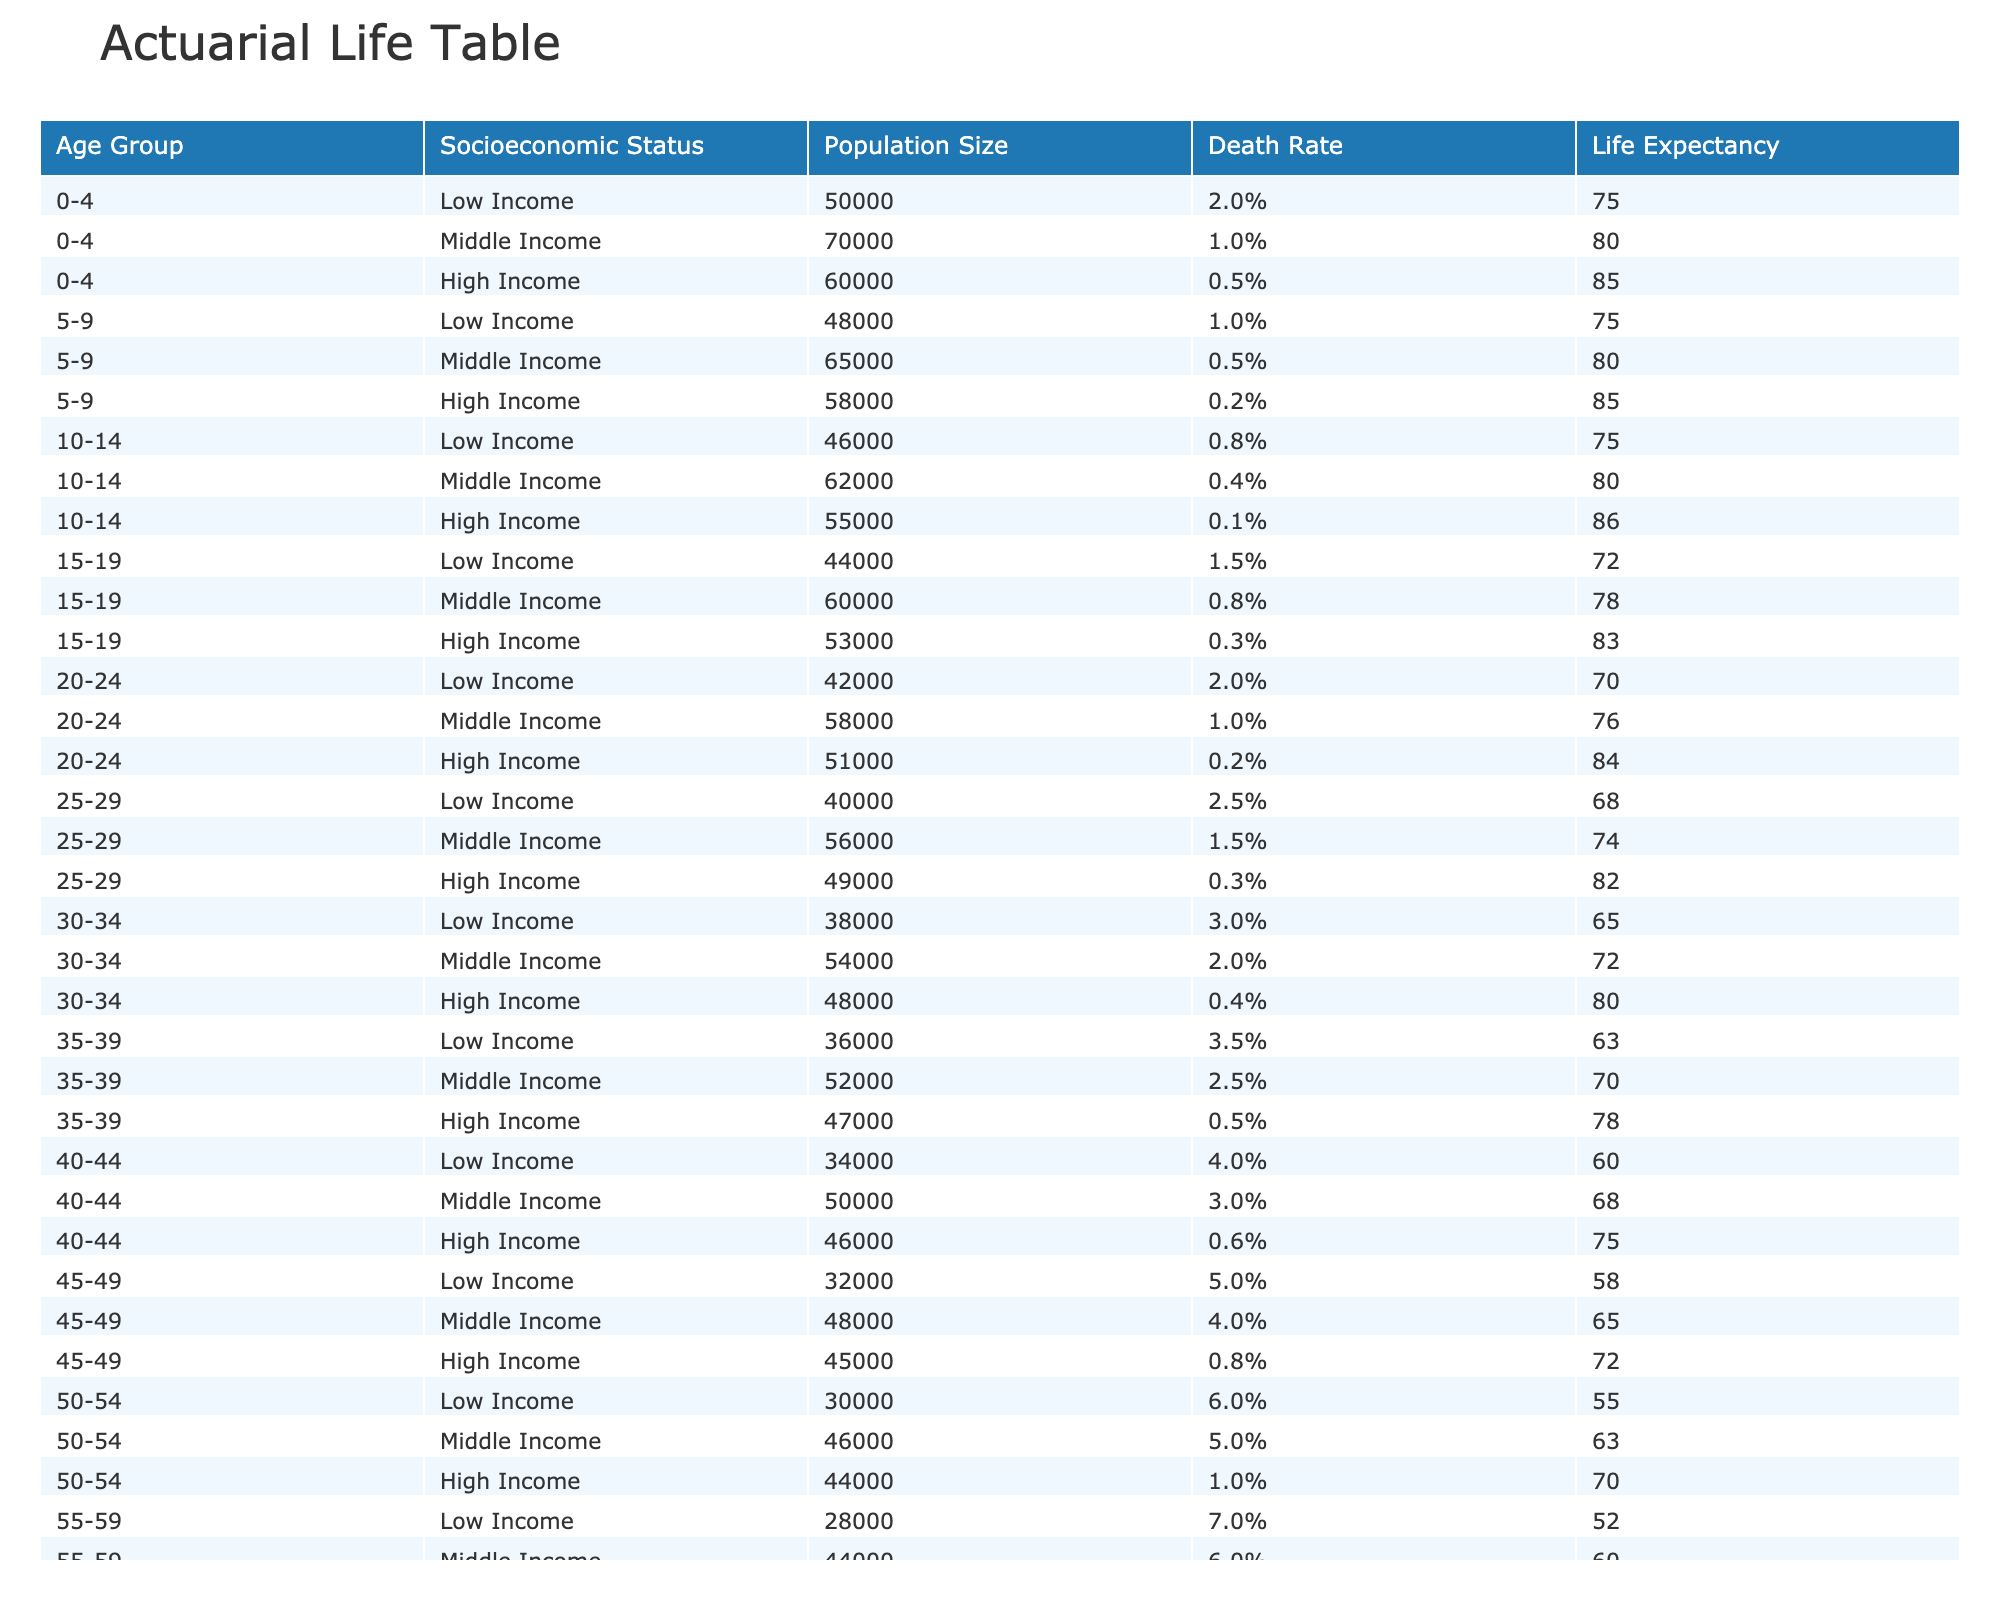What is the life expectancy for the 0-4 age group in the High Income category? The table shows that the life expectancy for the 0-4 age group in the High Income category is 85 years. This can be retrieved directly from the corresponding row for the age group.
Answer: 85 What is the death rate for the 55-59 age group in the Low Income category? The table lists the death rate for the 55-59 age group in the Low Income category as 7.0%. This value can be found in the respective row under the "Death Rate" column.
Answer: 7.0% For the 30-34 age group, which socioeconomic status has the lowest life expectancy? The table indicates that among the 30-34 age group, Low Income has the lowest life expectancy of 65 years, compared to 72 years for Middle Income and 80 years for High Income.
Answer: Low Income What is the average death rate for the 5-9 age group across all socioeconomic groups? To calculate the average death rate for the 5-9 age group, we sum the death rates of all three socioeconomic groups: 0.01 (Low) + 0.005 (Middle) + 0.002 (High) = 0.017. Then, we divide by the number of groups (3), resulting in an average of 0.017/3 = 0.00567 or approximately 0.57%.
Answer: 0.57% Is the life expectancy for the 75-79 age group in the Middle Income category higher than that in the Low Income category? From the table, the life expectancy for the 75-79 age group in the Middle Income category is 50 years, whereas in the Low Income category, it is 39 years. Therefore, 50 is greater than 39, confirming this statement is true.
Answer: Yes Which socioeconomic status has the highest death rate among the 80+ age group? Looking at the table, the Low Income category has the highest death rate at 15.0% for the 80+ age group. This is identified by comparing the death rates provided for each status in that age range.
Answer: Low Income What is the difference in life expectancy between the 40-44 age group in High Income and Low Income categories? The life expectancy for the 40-44 age group in High Income is 75 years, while in Low Income it is 60 years. The difference is 75 - 60 = 15 years, indicating how socioeconomic status influences life longevity.
Answer: 15 years Does the Middle Income group show lower life expectancy than the High Income group for any age group listed? Yes, for every age group displayed in the table, the life expectancy for Middle Income is less than that of the High Income category, as evidenced by the respective values across all age ranges.
Answer: Yes 